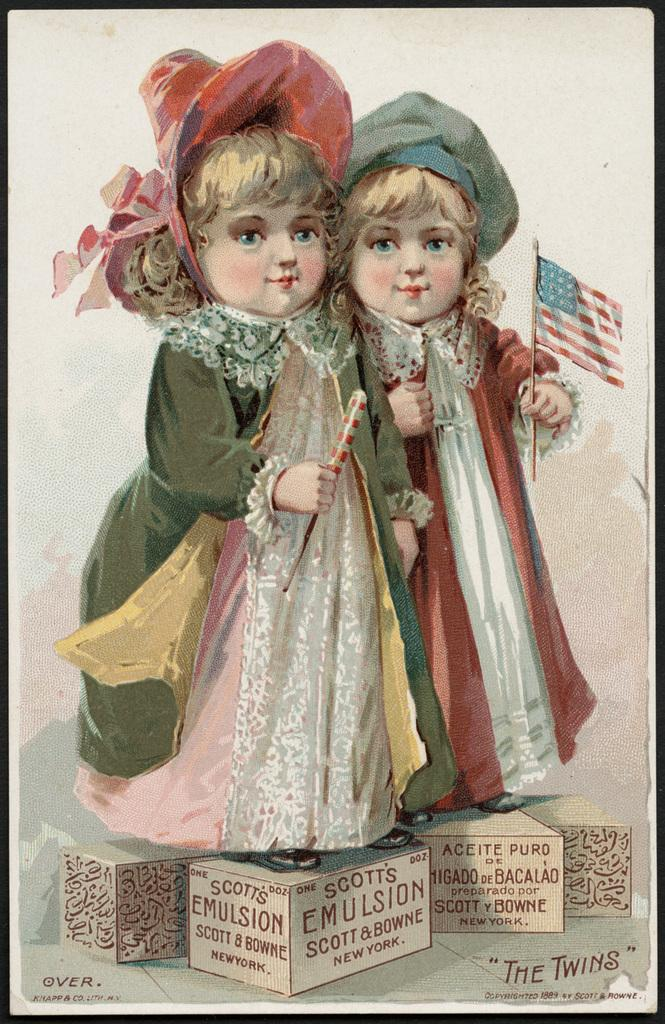What can be seen in the picture besides the girls? There is a poster in the picture. What are the girls holding in the picture? The girls are holding flags in the picture. What are the girls standing on in the picture? The girls are standing on cardboard boxes in the picture. What is written on the poster? There are words on the poster. What type of wire is being used to transmit the disease in the image? There is no wire or disease present in the image. What type of juice is being served to the girls in the image? There is no juice present in the image; the girls are holding flags and standing on cardboard boxes. 